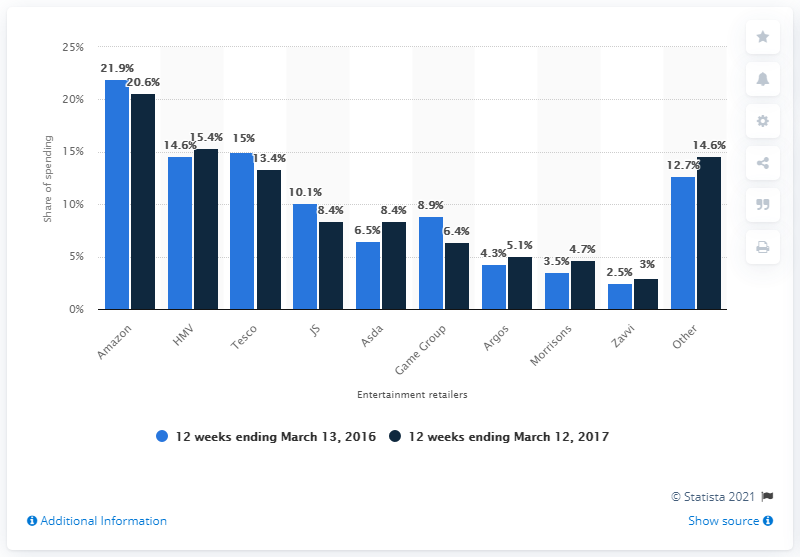Point out several critical features in this image. The difference between the highest retail share of JavaScript and the lowest retail share of Argos is 5.8%. HMV, an entertainment brand, experienced a significant increase in its market share growth from 14.6 percent in 2016 to 15.4 percent in 2017, outpacing its competitors. Amazon has consistently held the largest share of the entertainment market over the years. 